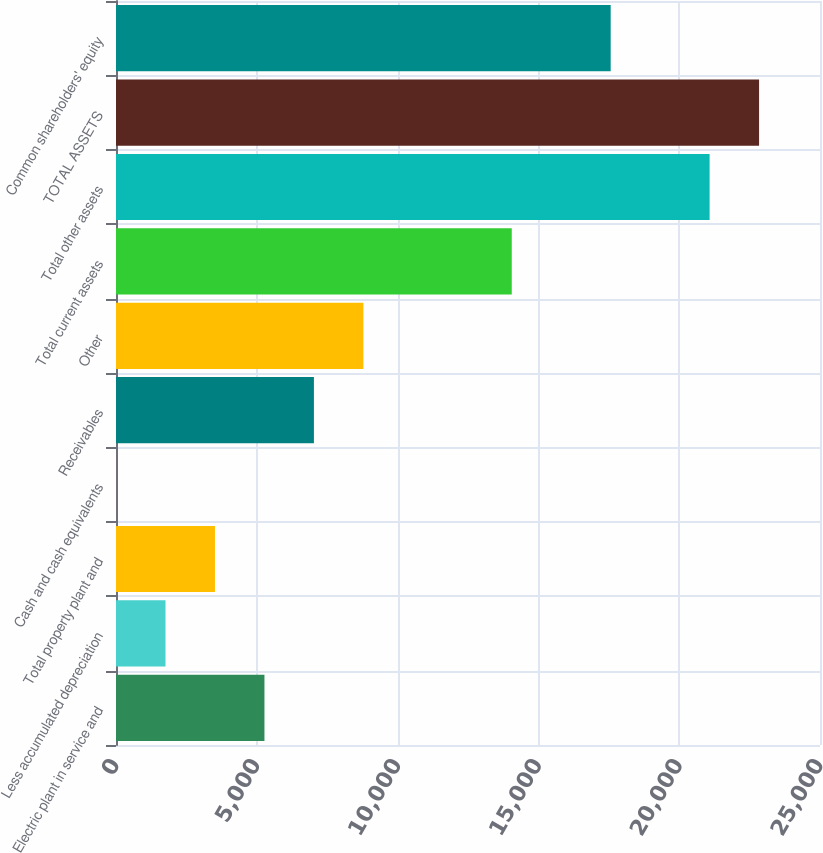<chart> <loc_0><loc_0><loc_500><loc_500><bar_chart><fcel>Electric plant in service and<fcel>Less accumulated depreciation<fcel>Total property plant and<fcel>Cash and cash equivalents<fcel>Receivables<fcel>Other<fcel>Total current assets<fcel>Total other assets<fcel>TOTAL ASSETS<fcel>Common shareholders' equity<nl><fcel>5271.5<fcel>1758.5<fcel>3515<fcel>2<fcel>7028<fcel>8784.5<fcel>14054<fcel>21080<fcel>22836.5<fcel>17567<nl></chart> 